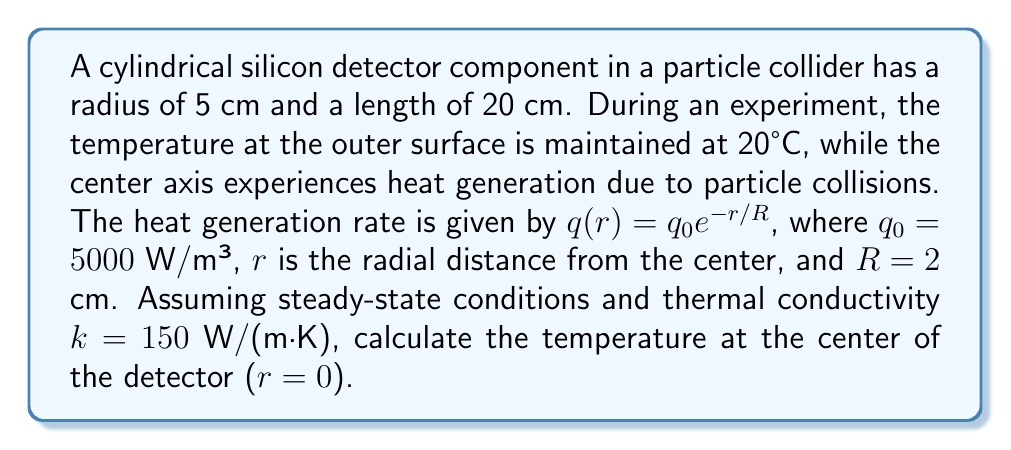Solve this math problem. To solve this problem, we'll use the steady-state heat equation in cylindrical coordinates with a heat generation term:

1) The governing equation is:
   $$\frac{1}{r}\frac{d}{dr}\left(r\frac{dT}{dr}\right) + \frac{q(r)}{k} = 0$$

2) Substitute $q(r) = q_0 e^{-r/R}$:
   $$\frac{1}{r}\frac{d}{dr}\left(r\frac{dT}{dr}\right) + \frac{q_0}{k} e^{-r/R} = 0$$

3) Integrate once:
   $$r\frac{dT}{dr} = -\frac{q_0R^2}{k}\left(1 - e^{-r/R}\right) + C_1$$

4) Divide by $r$ and integrate again:
   $$T(r) = -\frac{q_0R^2}{k}\left[\frac{1}{2}\left(\frac{r}{R}\right)^2 - \frac{R}{r}\left(1 - e^{-r/R}\right)\right] - C_1\ln(r) + C_2$$

5) Apply boundary conditions:
   At $r = R_0 = 0.05$ m, $T = 20°C$
   At $r = 0$, $\frac{dT}{dr} = 0$ (symmetry condition)

6) From the symmetry condition, $C_1 = 0$

7) From the surface temperature condition:
   $$20 = -\frac{q_0R^2}{k}\left[\frac{1}{2}\left(\frac{R_0}{R}\right)^2 - \frac{R}{R_0}\left(1 - e^{-R_0/R}\right)\right] + C_2$$

8) Solve for $C_2$:
   $$C_2 = 20 + \frac{q_0R^2}{k}\left[\frac{1}{2}\left(\frac{R_0}{R}\right)^2 - \frac{R}{R_0}\left(1 - e^{-R_0/R}\right)\right]$$

9) The temperature at the center ($r = 0$) is:
   $$T(0) = -\frac{q_0R^2}{k}\left[-1\right] + C_2 = \frac{q_0R^2}{k} + C_2$$

10) Substitute the values:
    $q_0 = 5000$ W/m³, $R = 0.02$ m, $k = 150$ W/(m·K), $R_0 = 0.05$ m

11) Calculate $C_2$ and $T(0)$
Answer: $T(0) \approx 26.7°C$ 